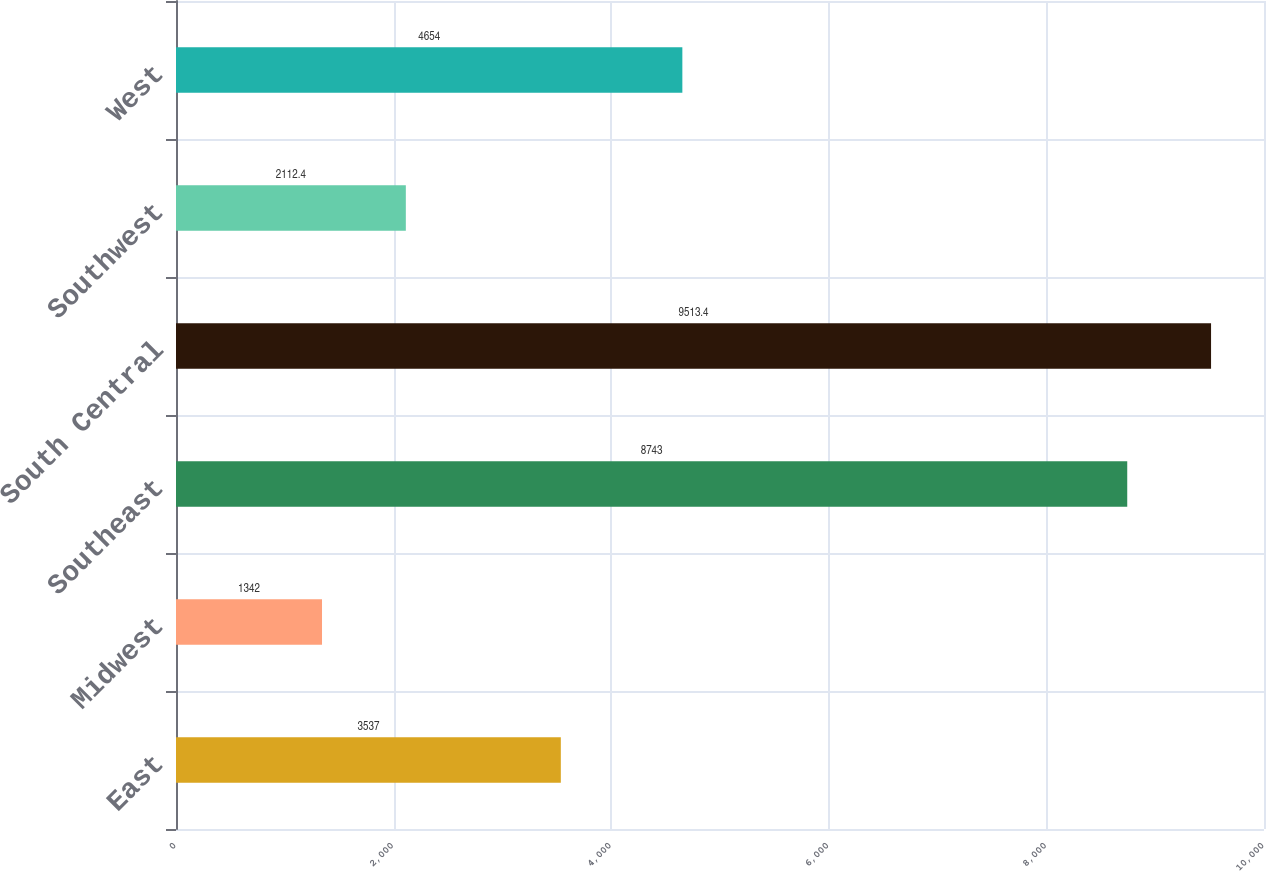Convert chart to OTSL. <chart><loc_0><loc_0><loc_500><loc_500><bar_chart><fcel>East<fcel>Midwest<fcel>Southeast<fcel>South Central<fcel>Southwest<fcel>West<nl><fcel>3537<fcel>1342<fcel>8743<fcel>9513.4<fcel>2112.4<fcel>4654<nl></chart> 